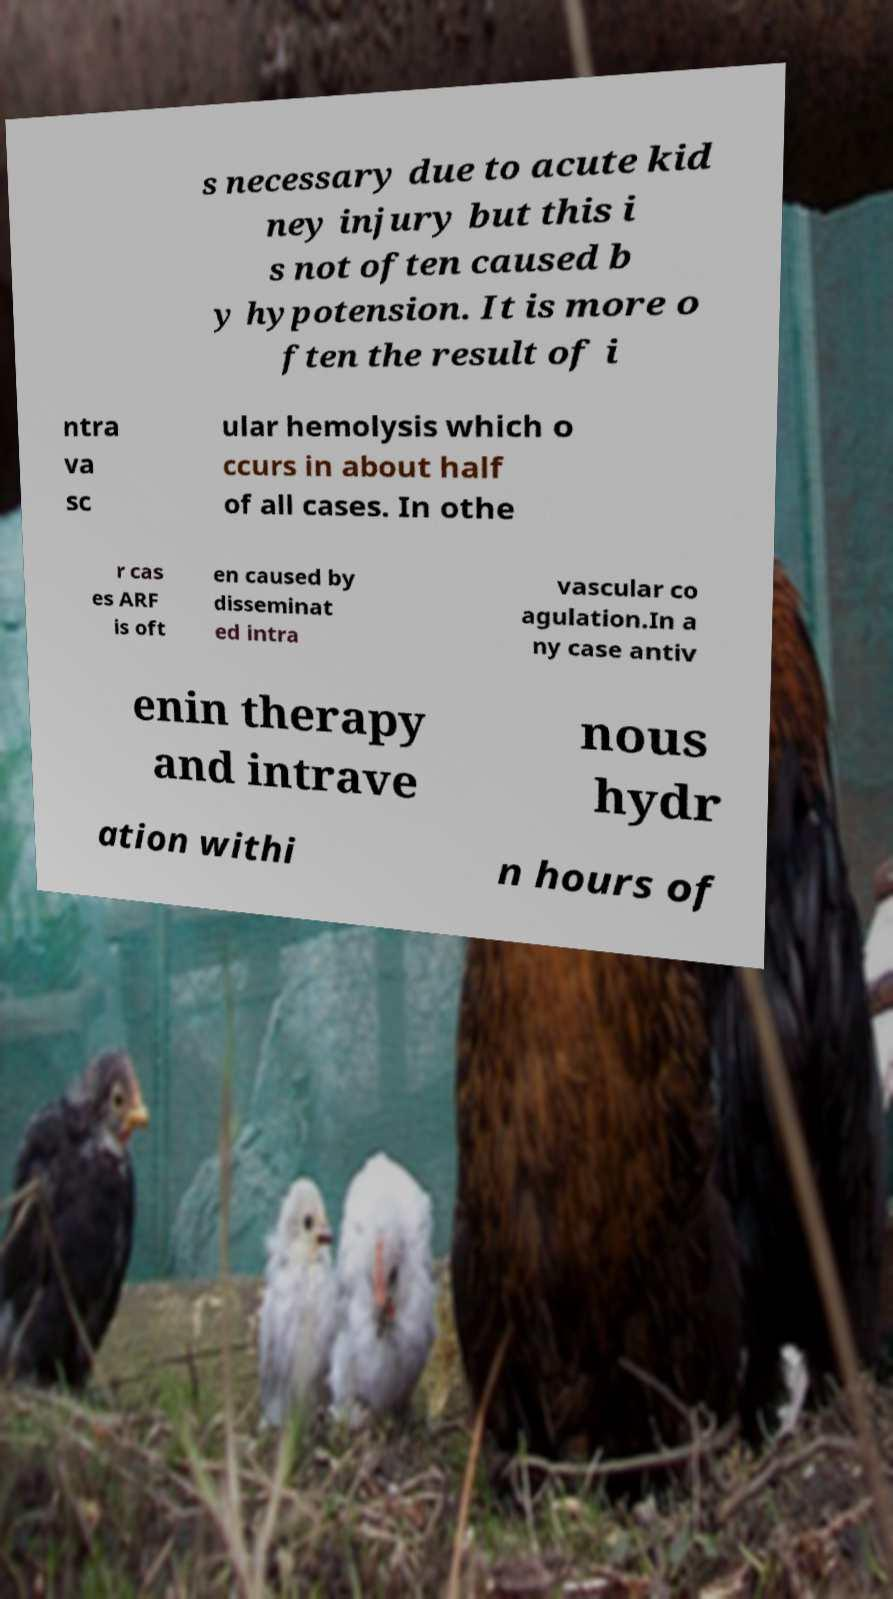Please identify and transcribe the text found in this image. s necessary due to acute kid ney injury but this i s not often caused b y hypotension. It is more o ften the result of i ntra va sc ular hemolysis which o ccurs in about half of all cases. In othe r cas es ARF is oft en caused by disseminat ed intra vascular co agulation.In a ny case antiv enin therapy and intrave nous hydr ation withi n hours of 